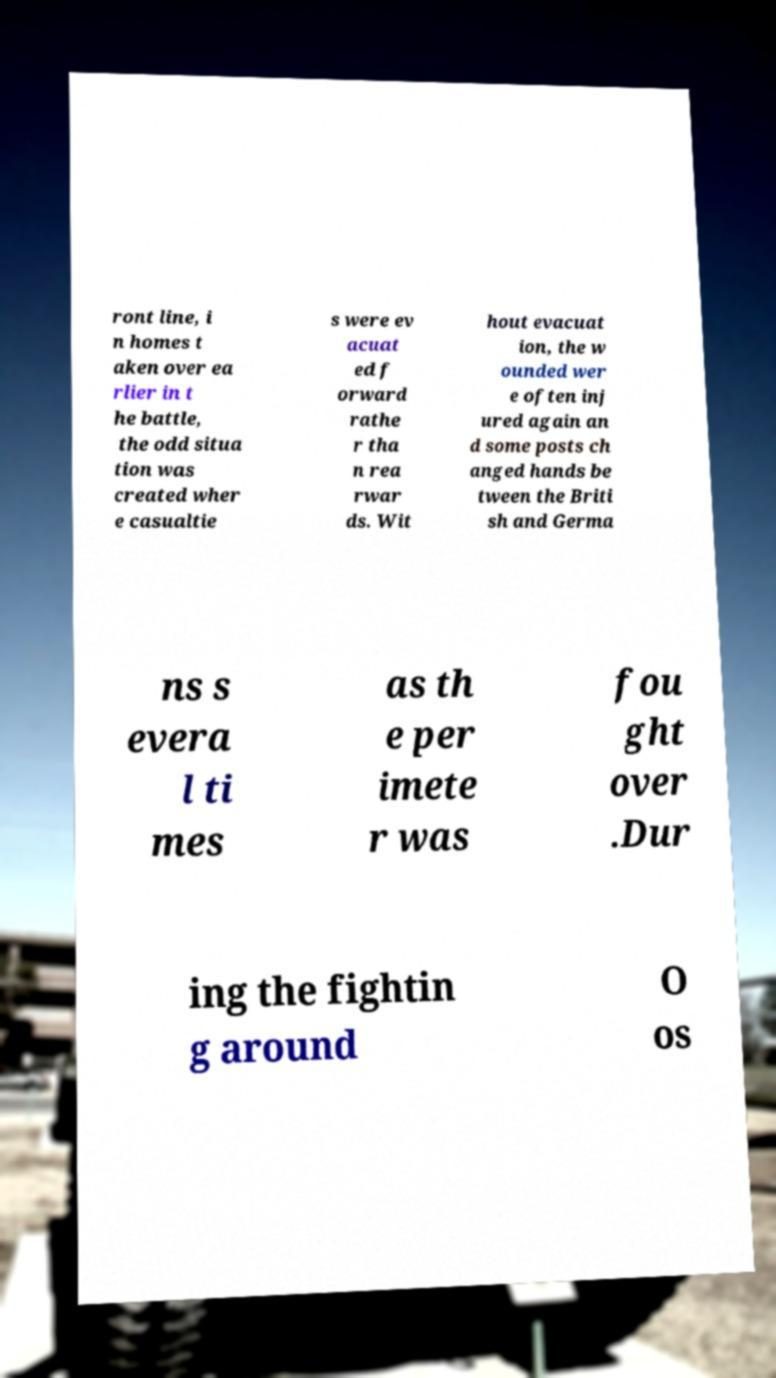What messages or text are displayed in this image? I need them in a readable, typed format. ront line, i n homes t aken over ea rlier in t he battle, the odd situa tion was created wher e casualtie s were ev acuat ed f orward rathe r tha n rea rwar ds. Wit hout evacuat ion, the w ounded wer e often inj ured again an d some posts ch anged hands be tween the Briti sh and Germa ns s evera l ti mes as th e per imete r was fou ght over .Dur ing the fightin g around O os 